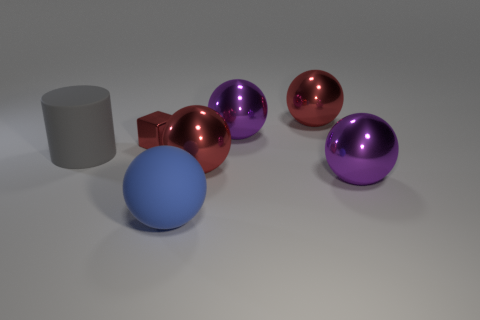Are there any other things that are the same size as the red cube?
Make the answer very short. No. Does the tiny metal cube have the same color as the rubber object in front of the large cylinder?
Give a very brief answer. No. There is a big blue matte ball; how many big red things are behind it?
Provide a short and direct response. 2. Are there fewer rubber cubes than rubber things?
Give a very brief answer. Yes. There is a red thing that is right of the metallic block and behind the large gray cylinder; how big is it?
Give a very brief answer. Large. Is the color of the matte object that is on the right side of the gray thing the same as the matte cylinder?
Give a very brief answer. No. Is the number of big gray cylinders behind the big blue matte object less than the number of blue objects?
Make the answer very short. No. What shape is the large blue object that is made of the same material as the large gray cylinder?
Offer a very short reply. Sphere. Is the material of the small thing the same as the blue ball?
Give a very brief answer. No. Are there fewer cylinders that are in front of the rubber cylinder than balls that are in front of the small thing?
Your answer should be very brief. Yes. 